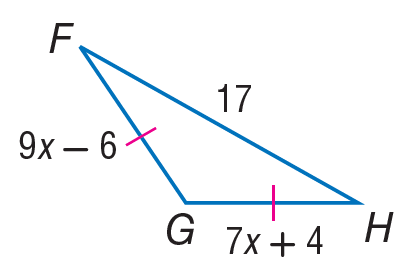Answer the mathemtical geometry problem and directly provide the correct option letter.
Question: Find G H.
Choices: A: 17 B: 35 C: 39 D: 45 C 